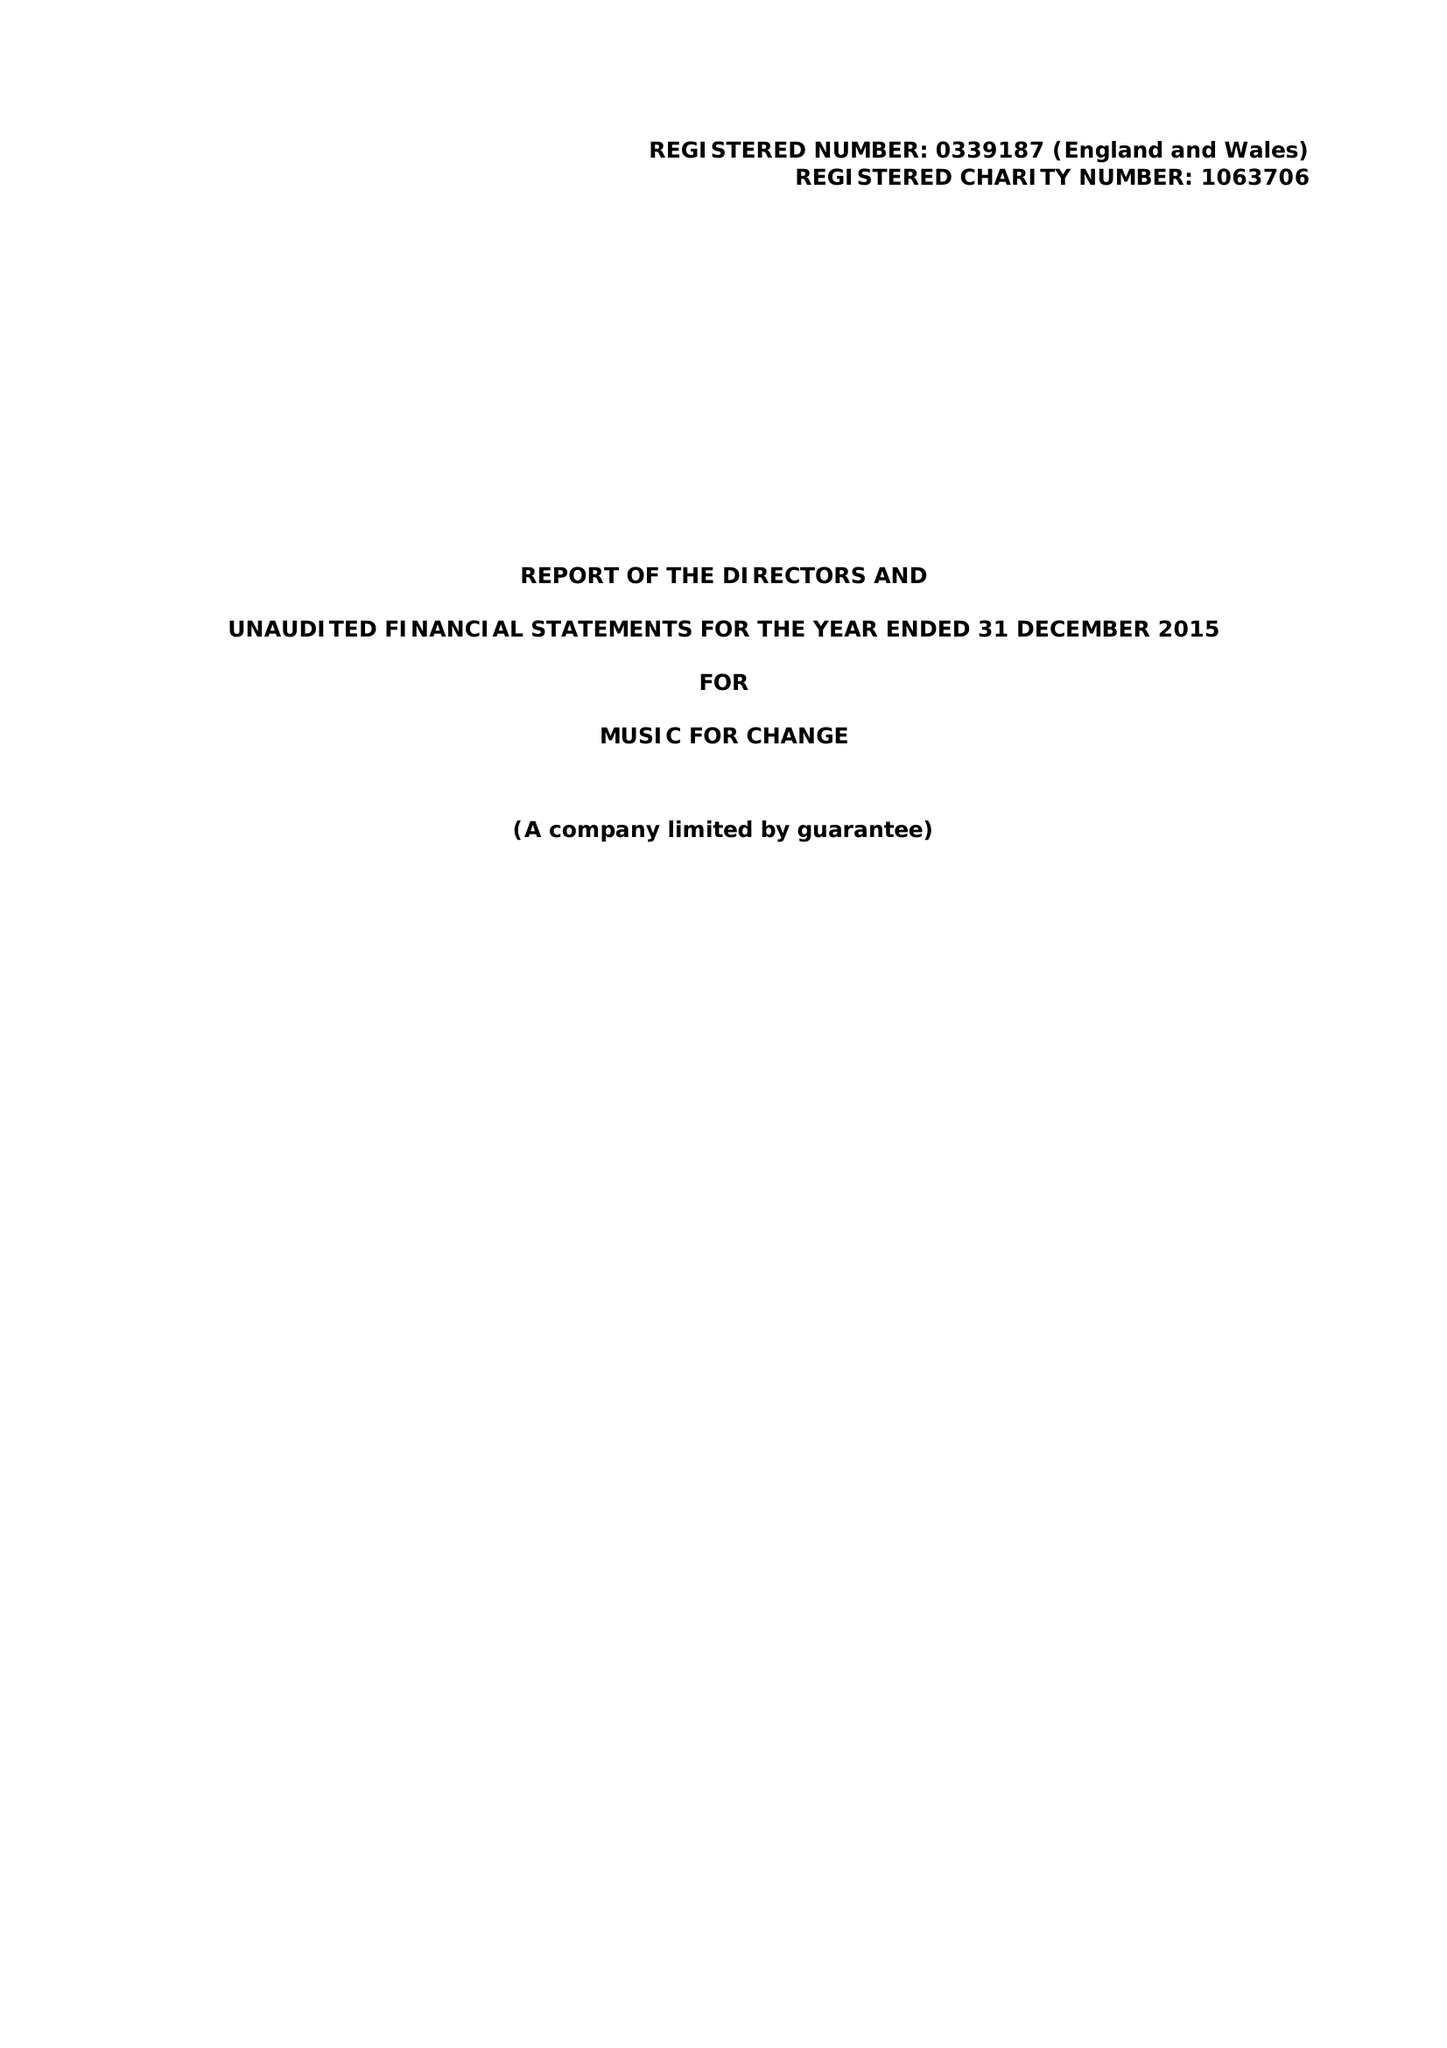What is the value for the spending_annually_in_british_pounds?
Answer the question using a single word or phrase. 130265.00 